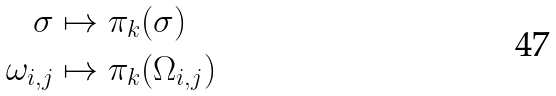Convert formula to latex. <formula><loc_0><loc_0><loc_500><loc_500>\sigma & \mapsto \pi _ { k } ( \sigma ) \\ \omega _ { i , j } & \mapsto \pi _ { k } ( \Omega _ { i , j } )</formula> 